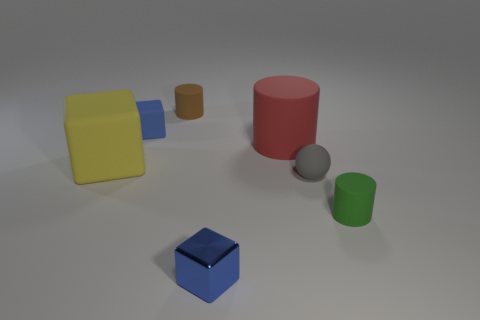Subtract all tiny metal cubes. How many cubes are left? 2 Subtract all yellow cylinders. How many blue blocks are left? 2 Add 2 yellow rubber objects. How many objects exist? 9 Subtract 1 cubes. How many cubes are left? 2 Subtract all brown cubes. Subtract all cyan cylinders. How many cubes are left? 3 Subtract 0 brown cubes. How many objects are left? 7 Subtract all spheres. How many objects are left? 6 Subtract all yellow shiny spheres. Subtract all tiny objects. How many objects are left? 2 Add 5 small rubber balls. How many small rubber balls are left? 6 Add 4 tiny green metal cylinders. How many tiny green metal cylinders exist? 4 